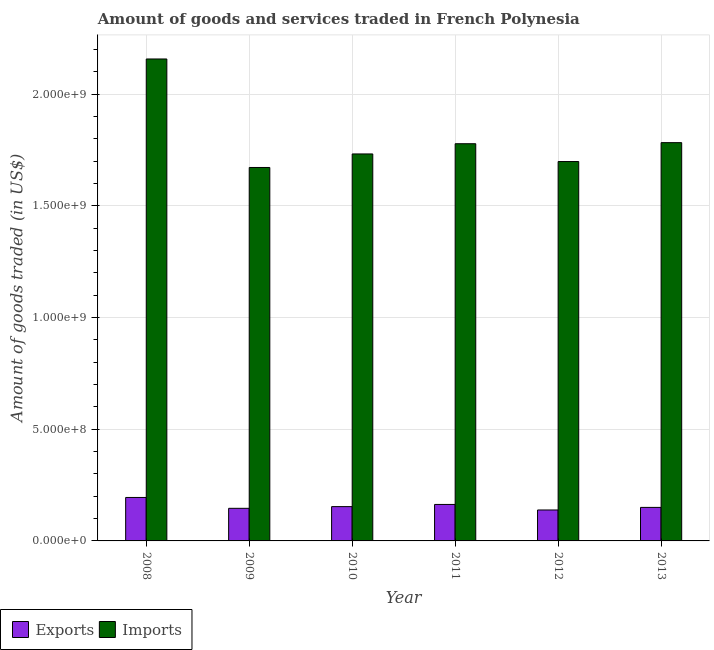How many groups of bars are there?
Your answer should be very brief. 6. How many bars are there on the 6th tick from the right?
Offer a terse response. 2. What is the amount of goods imported in 2013?
Your answer should be compact. 1.78e+09. Across all years, what is the maximum amount of goods exported?
Make the answer very short. 1.95e+08. Across all years, what is the minimum amount of goods imported?
Provide a succinct answer. 1.67e+09. In which year was the amount of goods exported minimum?
Give a very brief answer. 2012. What is the total amount of goods imported in the graph?
Give a very brief answer. 1.08e+1. What is the difference between the amount of goods imported in 2008 and that in 2009?
Offer a very short reply. 4.86e+08. What is the difference between the amount of goods imported in 2013 and the amount of goods exported in 2009?
Provide a succinct answer. 1.11e+08. What is the average amount of goods imported per year?
Offer a very short reply. 1.80e+09. What is the ratio of the amount of goods imported in 2011 to that in 2013?
Give a very brief answer. 1. Is the amount of goods exported in 2009 less than that in 2013?
Give a very brief answer. Yes. What is the difference between the highest and the second highest amount of goods imported?
Give a very brief answer. 3.75e+08. What is the difference between the highest and the lowest amount of goods imported?
Provide a succinct answer. 4.86e+08. In how many years, is the amount of goods exported greater than the average amount of goods exported taken over all years?
Ensure brevity in your answer.  2. Is the sum of the amount of goods imported in 2008 and 2010 greater than the maximum amount of goods exported across all years?
Provide a succinct answer. Yes. What does the 1st bar from the left in 2013 represents?
Make the answer very short. Exports. What does the 1st bar from the right in 2008 represents?
Offer a very short reply. Imports. How many bars are there?
Your answer should be very brief. 12. How many years are there in the graph?
Offer a terse response. 6. Are the values on the major ticks of Y-axis written in scientific E-notation?
Your response must be concise. Yes. Does the graph contain any zero values?
Give a very brief answer. No. Does the graph contain grids?
Keep it short and to the point. Yes. Where does the legend appear in the graph?
Give a very brief answer. Bottom left. How many legend labels are there?
Give a very brief answer. 2. How are the legend labels stacked?
Keep it short and to the point. Horizontal. What is the title of the graph?
Provide a short and direct response. Amount of goods and services traded in French Polynesia. What is the label or title of the Y-axis?
Make the answer very short. Amount of goods traded (in US$). What is the Amount of goods traded (in US$) in Exports in 2008?
Your answer should be very brief. 1.95e+08. What is the Amount of goods traded (in US$) in Imports in 2008?
Your answer should be compact. 2.16e+09. What is the Amount of goods traded (in US$) in Exports in 2009?
Offer a very short reply. 1.46e+08. What is the Amount of goods traded (in US$) of Imports in 2009?
Your answer should be compact. 1.67e+09. What is the Amount of goods traded (in US$) in Exports in 2010?
Your answer should be compact. 1.54e+08. What is the Amount of goods traded (in US$) in Imports in 2010?
Your answer should be compact. 1.73e+09. What is the Amount of goods traded (in US$) in Exports in 2011?
Give a very brief answer. 1.63e+08. What is the Amount of goods traded (in US$) of Imports in 2011?
Offer a terse response. 1.78e+09. What is the Amount of goods traded (in US$) of Exports in 2012?
Offer a terse response. 1.38e+08. What is the Amount of goods traded (in US$) in Imports in 2012?
Ensure brevity in your answer.  1.70e+09. What is the Amount of goods traded (in US$) in Exports in 2013?
Offer a very short reply. 1.50e+08. What is the Amount of goods traded (in US$) in Imports in 2013?
Give a very brief answer. 1.78e+09. Across all years, what is the maximum Amount of goods traded (in US$) in Exports?
Offer a very short reply. 1.95e+08. Across all years, what is the maximum Amount of goods traded (in US$) of Imports?
Your response must be concise. 2.16e+09. Across all years, what is the minimum Amount of goods traded (in US$) of Exports?
Offer a very short reply. 1.38e+08. Across all years, what is the minimum Amount of goods traded (in US$) in Imports?
Provide a short and direct response. 1.67e+09. What is the total Amount of goods traded (in US$) of Exports in the graph?
Your response must be concise. 9.46e+08. What is the total Amount of goods traded (in US$) of Imports in the graph?
Provide a succinct answer. 1.08e+1. What is the difference between the Amount of goods traded (in US$) in Exports in 2008 and that in 2009?
Your answer should be compact. 4.86e+07. What is the difference between the Amount of goods traded (in US$) in Imports in 2008 and that in 2009?
Make the answer very short. 4.86e+08. What is the difference between the Amount of goods traded (in US$) in Exports in 2008 and that in 2010?
Provide a succinct answer. 4.10e+07. What is the difference between the Amount of goods traded (in US$) in Imports in 2008 and that in 2010?
Your answer should be compact. 4.25e+08. What is the difference between the Amount of goods traded (in US$) in Exports in 2008 and that in 2011?
Give a very brief answer. 3.13e+07. What is the difference between the Amount of goods traded (in US$) in Imports in 2008 and that in 2011?
Offer a very short reply. 3.79e+08. What is the difference between the Amount of goods traded (in US$) of Exports in 2008 and that in 2012?
Your answer should be compact. 5.61e+07. What is the difference between the Amount of goods traded (in US$) of Imports in 2008 and that in 2012?
Offer a terse response. 4.59e+08. What is the difference between the Amount of goods traded (in US$) of Exports in 2008 and that in 2013?
Your response must be concise. 4.45e+07. What is the difference between the Amount of goods traded (in US$) in Imports in 2008 and that in 2013?
Give a very brief answer. 3.75e+08. What is the difference between the Amount of goods traded (in US$) in Exports in 2009 and that in 2010?
Your answer should be very brief. -7.60e+06. What is the difference between the Amount of goods traded (in US$) of Imports in 2009 and that in 2010?
Ensure brevity in your answer.  -6.06e+07. What is the difference between the Amount of goods traded (in US$) of Exports in 2009 and that in 2011?
Ensure brevity in your answer.  -1.73e+07. What is the difference between the Amount of goods traded (in US$) of Imports in 2009 and that in 2011?
Offer a very short reply. -1.06e+08. What is the difference between the Amount of goods traded (in US$) in Exports in 2009 and that in 2012?
Offer a very short reply. 7.45e+06. What is the difference between the Amount of goods traded (in US$) in Imports in 2009 and that in 2012?
Your answer should be compact. -2.66e+07. What is the difference between the Amount of goods traded (in US$) of Exports in 2009 and that in 2013?
Give a very brief answer. -4.11e+06. What is the difference between the Amount of goods traded (in US$) of Imports in 2009 and that in 2013?
Make the answer very short. -1.11e+08. What is the difference between the Amount of goods traded (in US$) in Exports in 2010 and that in 2011?
Provide a succinct answer. -9.71e+06. What is the difference between the Amount of goods traded (in US$) in Imports in 2010 and that in 2011?
Make the answer very short. -4.57e+07. What is the difference between the Amount of goods traded (in US$) in Exports in 2010 and that in 2012?
Ensure brevity in your answer.  1.50e+07. What is the difference between the Amount of goods traded (in US$) in Imports in 2010 and that in 2012?
Keep it short and to the point. 3.40e+07. What is the difference between the Amount of goods traded (in US$) of Exports in 2010 and that in 2013?
Give a very brief answer. 3.48e+06. What is the difference between the Amount of goods traded (in US$) of Imports in 2010 and that in 2013?
Offer a very short reply. -5.05e+07. What is the difference between the Amount of goods traded (in US$) of Exports in 2011 and that in 2012?
Give a very brief answer. 2.48e+07. What is the difference between the Amount of goods traded (in US$) of Imports in 2011 and that in 2012?
Your response must be concise. 7.98e+07. What is the difference between the Amount of goods traded (in US$) in Exports in 2011 and that in 2013?
Offer a very short reply. 1.32e+07. What is the difference between the Amount of goods traded (in US$) of Imports in 2011 and that in 2013?
Your response must be concise. -4.80e+06. What is the difference between the Amount of goods traded (in US$) in Exports in 2012 and that in 2013?
Keep it short and to the point. -1.16e+07. What is the difference between the Amount of goods traded (in US$) of Imports in 2012 and that in 2013?
Your answer should be compact. -8.46e+07. What is the difference between the Amount of goods traded (in US$) of Exports in 2008 and the Amount of goods traded (in US$) of Imports in 2009?
Provide a short and direct response. -1.48e+09. What is the difference between the Amount of goods traded (in US$) in Exports in 2008 and the Amount of goods traded (in US$) in Imports in 2010?
Offer a terse response. -1.54e+09. What is the difference between the Amount of goods traded (in US$) of Exports in 2008 and the Amount of goods traded (in US$) of Imports in 2011?
Provide a short and direct response. -1.58e+09. What is the difference between the Amount of goods traded (in US$) in Exports in 2008 and the Amount of goods traded (in US$) in Imports in 2012?
Provide a short and direct response. -1.50e+09. What is the difference between the Amount of goods traded (in US$) in Exports in 2008 and the Amount of goods traded (in US$) in Imports in 2013?
Your response must be concise. -1.59e+09. What is the difference between the Amount of goods traded (in US$) in Exports in 2009 and the Amount of goods traded (in US$) in Imports in 2010?
Give a very brief answer. -1.59e+09. What is the difference between the Amount of goods traded (in US$) of Exports in 2009 and the Amount of goods traded (in US$) of Imports in 2011?
Your answer should be compact. -1.63e+09. What is the difference between the Amount of goods traded (in US$) of Exports in 2009 and the Amount of goods traded (in US$) of Imports in 2012?
Your answer should be very brief. -1.55e+09. What is the difference between the Amount of goods traded (in US$) in Exports in 2009 and the Amount of goods traded (in US$) in Imports in 2013?
Keep it short and to the point. -1.64e+09. What is the difference between the Amount of goods traded (in US$) of Exports in 2010 and the Amount of goods traded (in US$) of Imports in 2011?
Make the answer very short. -1.62e+09. What is the difference between the Amount of goods traded (in US$) of Exports in 2010 and the Amount of goods traded (in US$) of Imports in 2012?
Offer a terse response. -1.54e+09. What is the difference between the Amount of goods traded (in US$) of Exports in 2010 and the Amount of goods traded (in US$) of Imports in 2013?
Provide a succinct answer. -1.63e+09. What is the difference between the Amount of goods traded (in US$) in Exports in 2011 and the Amount of goods traded (in US$) in Imports in 2012?
Ensure brevity in your answer.  -1.53e+09. What is the difference between the Amount of goods traded (in US$) of Exports in 2011 and the Amount of goods traded (in US$) of Imports in 2013?
Offer a very short reply. -1.62e+09. What is the difference between the Amount of goods traded (in US$) of Exports in 2012 and the Amount of goods traded (in US$) of Imports in 2013?
Your answer should be very brief. -1.64e+09. What is the average Amount of goods traded (in US$) in Exports per year?
Your answer should be very brief. 1.58e+08. What is the average Amount of goods traded (in US$) in Imports per year?
Your response must be concise. 1.80e+09. In the year 2008, what is the difference between the Amount of goods traded (in US$) in Exports and Amount of goods traded (in US$) in Imports?
Make the answer very short. -1.96e+09. In the year 2009, what is the difference between the Amount of goods traded (in US$) in Exports and Amount of goods traded (in US$) in Imports?
Offer a very short reply. -1.53e+09. In the year 2010, what is the difference between the Amount of goods traded (in US$) in Exports and Amount of goods traded (in US$) in Imports?
Your answer should be very brief. -1.58e+09. In the year 2011, what is the difference between the Amount of goods traded (in US$) of Exports and Amount of goods traded (in US$) of Imports?
Provide a succinct answer. -1.61e+09. In the year 2012, what is the difference between the Amount of goods traded (in US$) in Exports and Amount of goods traded (in US$) in Imports?
Your answer should be very brief. -1.56e+09. In the year 2013, what is the difference between the Amount of goods traded (in US$) of Exports and Amount of goods traded (in US$) of Imports?
Provide a succinct answer. -1.63e+09. What is the ratio of the Amount of goods traded (in US$) of Exports in 2008 to that in 2009?
Your response must be concise. 1.33. What is the ratio of the Amount of goods traded (in US$) of Imports in 2008 to that in 2009?
Your answer should be very brief. 1.29. What is the ratio of the Amount of goods traded (in US$) of Exports in 2008 to that in 2010?
Ensure brevity in your answer.  1.27. What is the ratio of the Amount of goods traded (in US$) in Imports in 2008 to that in 2010?
Give a very brief answer. 1.25. What is the ratio of the Amount of goods traded (in US$) in Exports in 2008 to that in 2011?
Make the answer very short. 1.19. What is the ratio of the Amount of goods traded (in US$) of Imports in 2008 to that in 2011?
Your answer should be very brief. 1.21. What is the ratio of the Amount of goods traded (in US$) in Exports in 2008 to that in 2012?
Provide a short and direct response. 1.4. What is the ratio of the Amount of goods traded (in US$) of Imports in 2008 to that in 2012?
Keep it short and to the point. 1.27. What is the ratio of the Amount of goods traded (in US$) of Exports in 2008 to that in 2013?
Give a very brief answer. 1.3. What is the ratio of the Amount of goods traded (in US$) of Imports in 2008 to that in 2013?
Provide a succinct answer. 1.21. What is the ratio of the Amount of goods traded (in US$) of Exports in 2009 to that in 2010?
Your response must be concise. 0.95. What is the ratio of the Amount of goods traded (in US$) in Imports in 2009 to that in 2010?
Make the answer very short. 0.96. What is the ratio of the Amount of goods traded (in US$) in Exports in 2009 to that in 2011?
Ensure brevity in your answer.  0.89. What is the ratio of the Amount of goods traded (in US$) in Imports in 2009 to that in 2011?
Keep it short and to the point. 0.94. What is the ratio of the Amount of goods traded (in US$) of Exports in 2009 to that in 2012?
Provide a short and direct response. 1.05. What is the ratio of the Amount of goods traded (in US$) of Imports in 2009 to that in 2012?
Give a very brief answer. 0.98. What is the ratio of the Amount of goods traded (in US$) of Exports in 2009 to that in 2013?
Your answer should be very brief. 0.97. What is the ratio of the Amount of goods traded (in US$) in Imports in 2009 to that in 2013?
Keep it short and to the point. 0.94. What is the ratio of the Amount of goods traded (in US$) in Exports in 2010 to that in 2011?
Keep it short and to the point. 0.94. What is the ratio of the Amount of goods traded (in US$) in Imports in 2010 to that in 2011?
Make the answer very short. 0.97. What is the ratio of the Amount of goods traded (in US$) of Exports in 2010 to that in 2012?
Provide a succinct answer. 1.11. What is the ratio of the Amount of goods traded (in US$) of Imports in 2010 to that in 2012?
Provide a short and direct response. 1.02. What is the ratio of the Amount of goods traded (in US$) of Exports in 2010 to that in 2013?
Your response must be concise. 1.02. What is the ratio of the Amount of goods traded (in US$) of Imports in 2010 to that in 2013?
Give a very brief answer. 0.97. What is the ratio of the Amount of goods traded (in US$) in Exports in 2011 to that in 2012?
Make the answer very short. 1.18. What is the ratio of the Amount of goods traded (in US$) in Imports in 2011 to that in 2012?
Your answer should be very brief. 1.05. What is the ratio of the Amount of goods traded (in US$) in Exports in 2011 to that in 2013?
Your answer should be very brief. 1.09. What is the ratio of the Amount of goods traded (in US$) in Imports in 2011 to that in 2013?
Give a very brief answer. 1. What is the ratio of the Amount of goods traded (in US$) in Exports in 2012 to that in 2013?
Provide a short and direct response. 0.92. What is the ratio of the Amount of goods traded (in US$) in Imports in 2012 to that in 2013?
Offer a very short reply. 0.95. What is the difference between the highest and the second highest Amount of goods traded (in US$) in Exports?
Give a very brief answer. 3.13e+07. What is the difference between the highest and the second highest Amount of goods traded (in US$) of Imports?
Keep it short and to the point. 3.75e+08. What is the difference between the highest and the lowest Amount of goods traded (in US$) of Exports?
Give a very brief answer. 5.61e+07. What is the difference between the highest and the lowest Amount of goods traded (in US$) in Imports?
Make the answer very short. 4.86e+08. 